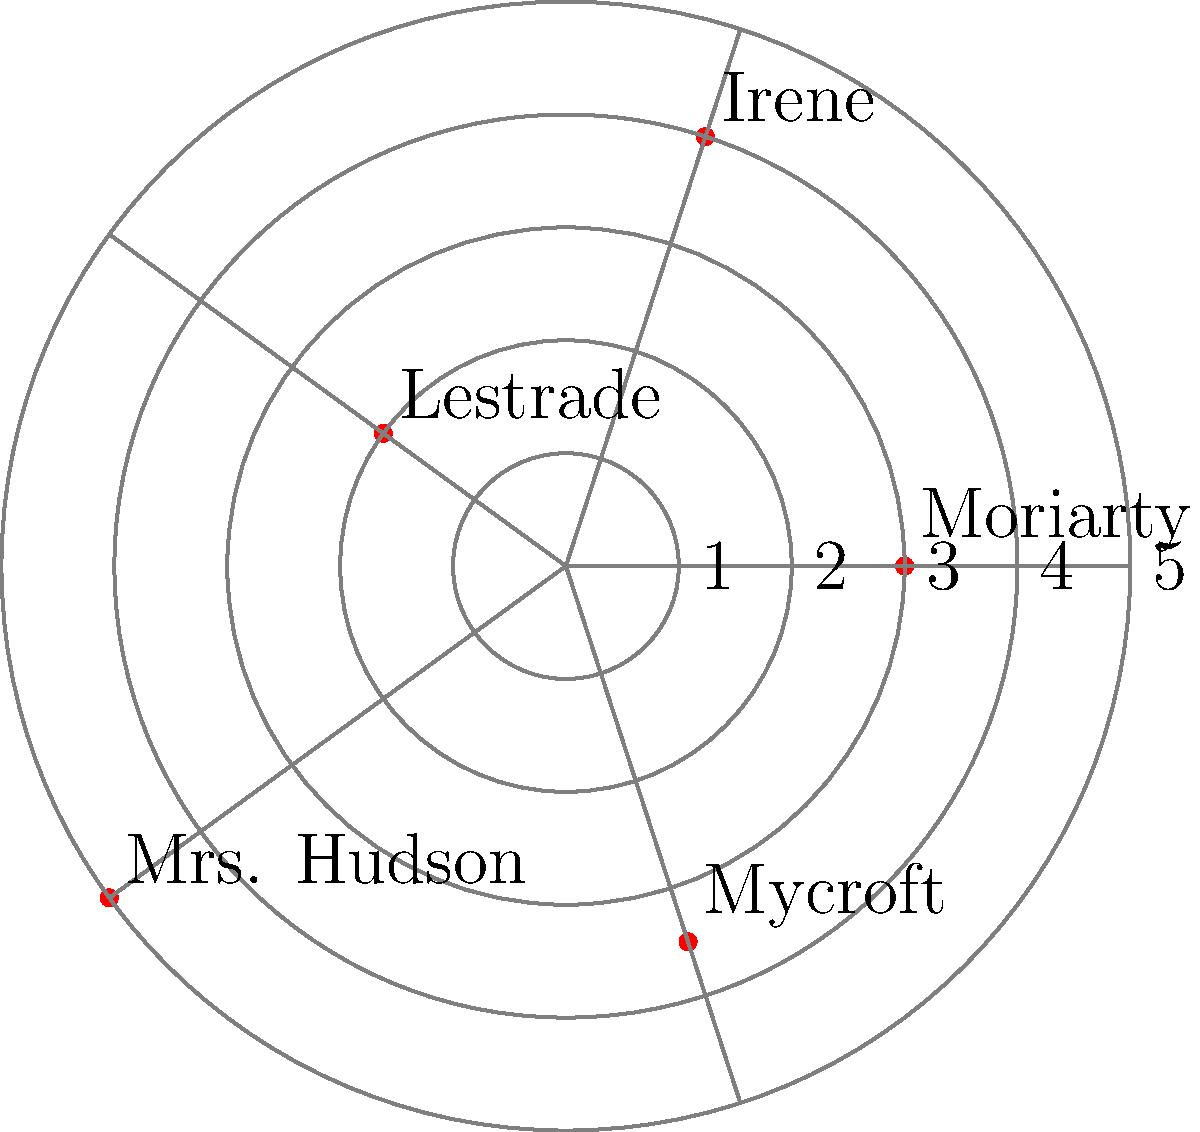In this Sherlock Holmes-themed challenge, suspects are positioned on a polar plot. The culprit is known to be exactly $\frac{\pi}{2}$ radians counterclockwise from the suspect with the largest radial coordinate, and has a radial coordinate that is the arithmetic mean of the two suspects closest to the origin. Who is the culprit? Let's approach this step-by-step:

1. First, identify the suspect with the largest radial coordinate:
   Mrs. Hudson has a radial coordinate of 5, which is the largest.

2. The culprit is $\frac{\pi}{2}$ radians (90 degrees) counterclockwise from Mrs. Hudson:
   This position corresponds to Mycroft's angular coordinate.

3. Now, identify the two suspects closest to the origin:
   Lestrade (r = 2) and Moriarty (r = 3) are closest to the origin.

4. Calculate the arithmetic mean of their radial coordinates:
   $\frac{2 + 3}{2} = 2.5$

5. Check if Mycroft's radial coordinate matches this mean:
   Mycroft's radial coordinate is 3.5, which does not match 2.5.

6. Therefore, Mycroft is not the culprit.

7. The only suspect that satisfies both conditions (90 degrees from Mrs. Hudson and radial coordinate of 2.5) is Irene.
Answer: Irene 